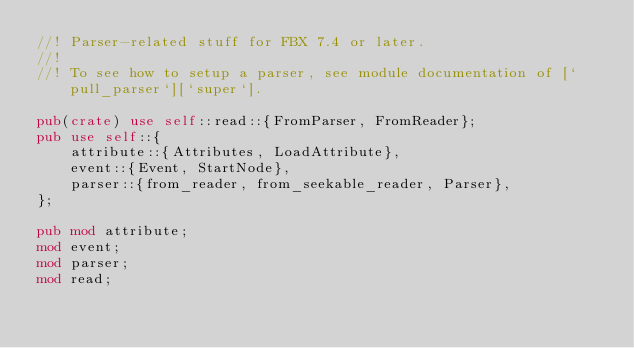<code> <loc_0><loc_0><loc_500><loc_500><_Rust_>//! Parser-related stuff for FBX 7.4 or later.
//!
//! To see how to setup a parser, see module documentation of [`pull_parser`][`super`].

pub(crate) use self::read::{FromParser, FromReader};
pub use self::{
    attribute::{Attributes, LoadAttribute},
    event::{Event, StartNode},
    parser::{from_reader, from_seekable_reader, Parser},
};

pub mod attribute;
mod event;
mod parser;
mod read;
</code> 